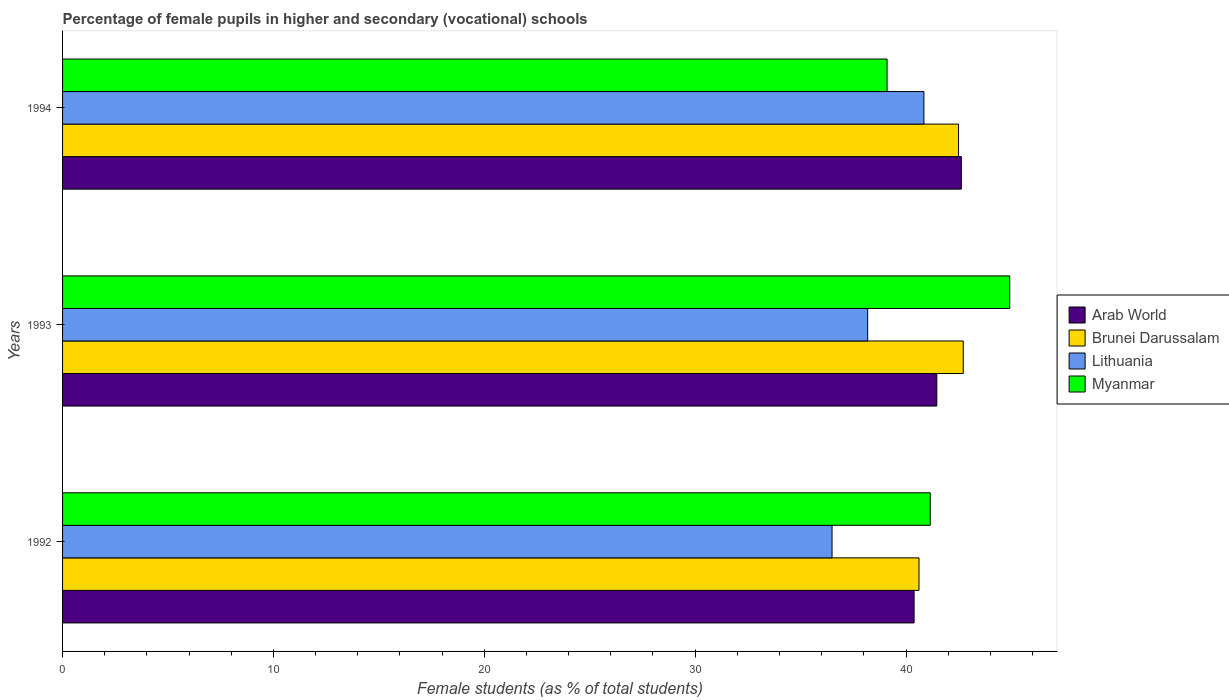How many different coloured bars are there?
Your answer should be compact. 4. How many groups of bars are there?
Provide a succinct answer. 3. How many bars are there on the 2nd tick from the top?
Your response must be concise. 4. What is the label of the 1st group of bars from the top?
Offer a very short reply. 1994. What is the percentage of female pupils in higher and secondary schools in Myanmar in 1993?
Your response must be concise. 44.92. Across all years, what is the maximum percentage of female pupils in higher and secondary schools in Myanmar?
Keep it short and to the point. 44.92. Across all years, what is the minimum percentage of female pupils in higher and secondary schools in Myanmar?
Provide a succinct answer. 39.1. In which year was the percentage of female pupils in higher and secondary schools in Lithuania minimum?
Your answer should be compact. 1992. What is the total percentage of female pupils in higher and secondary schools in Myanmar in the graph?
Your response must be concise. 125.17. What is the difference between the percentage of female pupils in higher and secondary schools in Myanmar in 1992 and that in 1994?
Give a very brief answer. 2.05. What is the difference between the percentage of female pupils in higher and secondary schools in Arab World in 1993 and the percentage of female pupils in higher and secondary schools in Brunei Darussalam in 1992?
Offer a terse response. 0.85. What is the average percentage of female pupils in higher and secondary schools in Arab World per year?
Your answer should be compact. 41.49. In the year 1992, what is the difference between the percentage of female pupils in higher and secondary schools in Lithuania and percentage of female pupils in higher and secondary schools in Arab World?
Give a very brief answer. -3.89. What is the ratio of the percentage of female pupils in higher and secondary schools in Arab World in 1992 to that in 1994?
Give a very brief answer. 0.95. Is the percentage of female pupils in higher and secondary schools in Brunei Darussalam in 1993 less than that in 1994?
Your answer should be compact. No. What is the difference between the highest and the second highest percentage of female pupils in higher and secondary schools in Arab World?
Your answer should be very brief. 1.16. What is the difference between the highest and the lowest percentage of female pupils in higher and secondary schools in Myanmar?
Your response must be concise. 5.82. Is the sum of the percentage of female pupils in higher and secondary schools in Arab World in 1993 and 1994 greater than the maximum percentage of female pupils in higher and secondary schools in Lithuania across all years?
Provide a short and direct response. Yes. Is it the case that in every year, the sum of the percentage of female pupils in higher and secondary schools in Brunei Darussalam and percentage of female pupils in higher and secondary schools in Lithuania is greater than the sum of percentage of female pupils in higher and secondary schools in Arab World and percentage of female pupils in higher and secondary schools in Myanmar?
Provide a short and direct response. No. What does the 1st bar from the top in 1992 represents?
Your response must be concise. Myanmar. What does the 2nd bar from the bottom in 1992 represents?
Offer a terse response. Brunei Darussalam. How many bars are there?
Your answer should be very brief. 12. How many years are there in the graph?
Your response must be concise. 3. What is the difference between two consecutive major ticks on the X-axis?
Provide a succinct answer. 10. Are the values on the major ticks of X-axis written in scientific E-notation?
Keep it short and to the point. No. Does the graph contain any zero values?
Give a very brief answer. No. Does the graph contain grids?
Your response must be concise. No. Where does the legend appear in the graph?
Ensure brevity in your answer.  Center right. How many legend labels are there?
Your answer should be compact. 4. How are the legend labels stacked?
Ensure brevity in your answer.  Vertical. What is the title of the graph?
Your answer should be compact. Percentage of female pupils in higher and secondary (vocational) schools. What is the label or title of the X-axis?
Provide a short and direct response. Female students (as % of total students). What is the label or title of the Y-axis?
Offer a very short reply. Years. What is the Female students (as % of total students) in Arab World in 1992?
Your response must be concise. 40.38. What is the Female students (as % of total students) of Brunei Darussalam in 1992?
Offer a very short reply. 40.62. What is the Female students (as % of total students) of Lithuania in 1992?
Provide a short and direct response. 36.49. What is the Female students (as % of total students) of Myanmar in 1992?
Offer a terse response. 41.15. What is the Female students (as % of total students) in Arab World in 1993?
Keep it short and to the point. 41.46. What is the Female students (as % of total students) of Brunei Darussalam in 1993?
Offer a terse response. 42.72. What is the Female students (as % of total students) in Lithuania in 1993?
Provide a short and direct response. 38.18. What is the Female students (as % of total students) of Myanmar in 1993?
Your answer should be compact. 44.92. What is the Female students (as % of total students) in Arab World in 1994?
Your answer should be very brief. 42.62. What is the Female students (as % of total students) of Brunei Darussalam in 1994?
Make the answer very short. 42.49. What is the Female students (as % of total students) in Lithuania in 1994?
Your answer should be compact. 40.85. What is the Female students (as % of total students) in Myanmar in 1994?
Make the answer very short. 39.1. Across all years, what is the maximum Female students (as % of total students) in Arab World?
Provide a short and direct response. 42.62. Across all years, what is the maximum Female students (as % of total students) in Brunei Darussalam?
Provide a short and direct response. 42.72. Across all years, what is the maximum Female students (as % of total students) in Lithuania?
Provide a short and direct response. 40.85. Across all years, what is the maximum Female students (as % of total students) of Myanmar?
Keep it short and to the point. 44.92. Across all years, what is the minimum Female students (as % of total students) in Arab World?
Your response must be concise. 40.38. Across all years, what is the minimum Female students (as % of total students) in Brunei Darussalam?
Ensure brevity in your answer.  40.62. Across all years, what is the minimum Female students (as % of total students) in Lithuania?
Keep it short and to the point. 36.49. Across all years, what is the minimum Female students (as % of total students) in Myanmar?
Keep it short and to the point. 39.1. What is the total Female students (as % of total students) of Arab World in the graph?
Provide a succinct answer. 124.47. What is the total Female students (as % of total students) of Brunei Darussalam in the graph?
Offer a very short reply. 125.82. What is the total Female students (as % of total students) of Lithuania in the graph?
Provide a succinct answer. 115.52. What is the total Female students (as % of total students) in Myanmar in the graph?
Your answer should be compact. 125.17. What is the difference between the Female students (as % of total students) in Arab World in 1992 and that in 1993?
Make the answer very short. -1.08. What is the difference between the Female students (as % of total students) of Brunei Darussalam in 1992 and that in 1993?
Make the answer very short. -2.1. What is the difference between the Female students (as % of total students) in Lithuania in 1992 and that in 1993?
Offer a very short reply. -1.69. What is the difference between the Female students (as % of total students) of Myanmar in 1992 and that in 1993?
Offer a terse response. -3.77. What is the difference between the Female students (as % of total students) in Arab World in 1992 and that in 1994?
Keep it short and to the point. -2.24. What is the difference between the Female students (as % of total students) of Brunei Darussalam in 1992 and that in 1994?
Offer a very short reply. -1.88. What is the difference between the Female students (as % of total students) of Lithuania in 1992 and that in 1994?
Your response must be concise. -4.36. What is the difference between the Female students (as % of total students) of Myanmar in 1992 and that in 1994?
Provide a succinct answer. 2.05. What is the difference between the Female students (as % of total students) of Arab World in 1993 and that in 1994?
Offer a very short reply. -1.16. What is the difference between the Female students (as % of total students) of Brunei Darussalam in 1993 and that in 1994?
Your answer should be compact. 0.22. What is the difference between the Female students (as % of total students) in Lithuania in 1993 and that in 1994?
Keep it short and to the point. -2.67. What is the difference between the Female students (as % of total students) of Myanmar in 1993 and that in 1994?
Your response must be concise. 5.82. What is the difference between the Female students (as % of total students) of Arab World in 1992 and the Female students (as % of total students) of Brunei Darussalam in 1993?
Your answer should be very brief. -2.33. What is the difference between the Female students (as % of total students) of Arab World in 1992 and the Female students (as % of total students) of Lithuania in 1993?
Make the answer very short. 2.2. What is the difference between the Female students (as % of total students) of Arab World in 1992 and the Female students (as % of total students) of Myanmar in 1993?
Offer a very short reply. -4.54. What is the difference between the Female students (as % of total students) in Brunei Darussalam in 1992 and the Female students (as % of total students) in Lithuania in 1993?
Give a very brief answer. 2.43. What is the difference between the Female students (as % of total students) of Brunei Darussalam in 1992 and the Female students (as % of total students) of Myanmar in 1993?
Offer a terse response. -4.3. What is the difference between the Female students (as % of total students) in Lithuania in 1992 and the Female students (as % of total students) in Myanmar in 1993?
Provide a succinct answer. -8.43. What is the difference between the Female students (as % of total students) of Arab World in 1992 and the Female students (as % of total students) of Brunei Darussalam in 1994?
Offer a terse response. -2.11. What is the difference between the Female students (as % of total students) of Arab World in 1992 and the Female students (as % of total students) of Lithuania in 1994?
Ensure brevity in your answer.  -0.47. What is the difference between the Female students (as % of total students) of Arab World in 1992 and the Female students (as % of total students) of Myanmar in 1994?
Your response must be concise. 1.28. What is the difference between the Female students (as % of total students) in Brunei Darussalam in 1992 and the Female students (as % of total students) in Lithuania in 1994?
Your answer should be very brief. -0.23. What is the difference between the Female students (as % of total students) of Brunei Darussalam in 1992 and the Female students (as % of total students) of Myanmar in 1994?
Offer a terse response. 1.51. What is the difference between the Female students (as % of total students) of Lithuania in 1992 and the Female students (as % of total students) of Myanmar in 1994?
Ensure brevity in your answer.  -2.61. What is the difference between the Female students (as % of total students) in Arab World in 1993 and the Female students (as % of total students) in Brunei Darussalam in 1994?
Give a very brief answer. -1.03. What is the difference between the Female students (as % of total students) in Arab World in 1993 and the Female students (as % of total students) in Lithuania in 1994?
Make the answer very short. 0.61. What is the difference between the Female students (as % of total students) in Arab World in 1993 and the Female students (as % of total students) in Myanmar in 1994?
Offer a very short reply. 2.36. What is the difference between the Female students (as % of total students) in Brunei Darussalam in 1993 and the Female students (as % of total students) in Lithuania in 1994?
Keep it short and to the point. 1.87. What is the difference between the Female students (as % of total students) in Brunei Darussalam in 1993 and the Female students (as % of total students) in Myanmar in 1994?
Your response must be concise. 3.61. What is the difference between the Female students (as % of total students) in Lithuania in 1993 and the Female students (as % of total students) in Myanmar in 1994?
Ensure brevity in your answer.  -0.92. What is the average Female students (as % of total students) in Arab World per year?
Make the answer very short. 41.49. What is the average Female students (as % of total students) in Brunei Darussalam per year?
Your response must be concise. 41.94. What is the average Female students (as % of total students) of Lithuania per year?
Provide a short and direct response. 38.51. What is the average Female students (as % of total students) of Myanmar per year?
Offer a very short reply. 41.72. In the year 1992, what is the difference between the Female students (as % of total students) in Arab World and Female students (as % of total students) in Brunei Darussalam?
Keep it short and to the point. -0.23. In the year 1992, what is the difference between the Female students (as % of total students) in Arab World and Female students (as % of total students) in Lithuania?
Offer a terse response. 3.89. In the year 1992, what is the difference between the Female students (as % of total students) of Arab World and Female students (as % of total students) of Myanmar?
Your answer should be very brief. -0.77. In the year 1992, what is the difference between the Female students (as % of total students) of Brunei Darussalam and Female students (as % of total students) of Lithuania?
Your answer should be very brief. 4.12. In the year 1992, what is the difference between the Female students (as % of total students) of Brunei Darussalam and Female students (as % of total students) of Myanmar?
Keep it short and to the point. -0.53. In the year 1992, what is the difference between the Female students (as % of total students) in Lithuania and Female students (as % of total students) in Myanmar?
Give a very brief answer. -4.66. In the year 1993, what is the difference between the Female students (as % of total students) of Arab World and Female students (as % of total students) of Brunei Darussalam?
Make the answer very short. -1.25. In the year 1993, what is the difference between the Female students (as % of total students) of Arab World and Female students (as % of total students) of Lithuania?
Make the answer very short. 3.28. In the year 1993, what is the difference between the Female students (as % of total students) in Arab World and Female students (as % of total students) in Myanmar?
Your answer should be compact. -3.46. In the year 1993, what is the difference between the Female students (as % of total students) of Brunei Darussalam and Female students (as % of total students) of Lithuania?
Give a very brief answer. 4.53. In the year 1993, what is the difference between the Female students (as % of total students) of Brunei Darussalam and Female students (as % of total students) of Myanmar?
Your answer should be compact. -2.2. In the year 1993, what is the difference between the Female students (as % of total students) in Lithuania and Female students (as % of total students) in Myanmar?
Keep it short and to the point. -6.74. In the year 1994, what is the difference between the Female students (as % of total students) in Arab World and Female students (as % of total students) in Brunei Darussalam?
Offer a very short reply. 0.13. In the year 1994, what is the difference between the Female students (as % of total students) in Arab World and Female students (as % of total students) in Lithuania?
Keep it short and to the point. 1.77. In the year 1994, what is the difference between the Female students (as % of total students) in Arab World and Female students (as % of total students) in Myanmar?
Keep it short and to the point. 3.52. In the year 1994, what is the difference between the Female students (as % of total students) of Brunei Darussalam and Female students (as % of total students) of Lithuania?
Give a very brief answer. 1.64. In the year 1994, what is the difference between the Female students (as % of total students) of Brunei Darussalam and Female students (as % of total students) of Myanmar?
Keep it short and to the point. 3.39. In the year 1994, what is the difference between the Female students (as % of total students) in Lithuania and Female students (as % of total students) in Myanmar?
Your answer should be very brief. 1.75. What is the ratio of the Female students (as % of total students) of Arab World in 1992 to that in 1993?
Your answer should be compact. 0.97. What is the ratio of the Female students (as % of total students) in Brunei Darussalam in 1992 to that in 1993?
Keep it short and to the point. 0.95. What is the ratio of the Female students (as % of total students) in Lithuania in 1992 to that in 1993?
Your answer should be very brief. 0.96. What is the ratio of the Female students (as % of total students) in Myanmar in 1992 to that in 1993?
Your answer should be compact. 0.92. What is the ratio of the Female students (as % of total students) of Arab World in 1992 to that in 1994?
Your answer should be very brief. 0.95. What is the ratio of the Female students (as % of total students) in Brunei Darussalam in 1992 to that in 1994?
Ensure brevity in your answer.  0.96. What is the ratio of the Female students (as % of total students) in Lithuania in 1992 to that in 1994?
Offer a terse response. 0.89. What is the ratio of the Female students (as % of total students) of Myanmar in 1992 to that in 1994?
Your response must be concise. 1.05. What is the ratio of the Female students (as % of total students) of Arab World in 1993 to that in 1994?
Your answer should be very brief. 0.97. What is the ratio of the Female students (as % of total students) of Brunei Darussalam in 1993 to that in 1994?
Your answer should be compact. 1.01. What is the ratio of the Female students (as % of total students) of Lithuania in 1993 to that in 1994?
Make the answer very short. 0.93. What is the ratio of the Female students (as % of total students) in Myanmar in 1993 to that in 1994?
Offer a terse response. 1.15. What is the difference between the highest and the second highest Female students (as % of total students) in Arab World?
Your answer should be very brief. 1.16. What is the difference between the highest and the second highest Female students (as % of total students) in Brunei Darussalam?
Make the answer very short. 0.22. What is the difference between the highest and the second highest Female students (as % of total students) of Lithuania?
Your answer should be very brief. 2.67. What is the difference between the highest and the second highest Female students (as % of total students) in Myanmar?
Offer a terse response. 3.77. What is the difference between the highest and the lowest Female students (as % of total students) of Arab World?
Keep it short and to the point. 2.24. What is the difference between the highest and the lowest Female students (as % of total students) in Brunei Darussalam?
Provide a succinct answer. 2.1. What is the difference between the highest and the lowest Female students (as % of total students) of Lithuania?
Provide a short and direct response. 4.36. What is the difference between the highest and the lowest Female students (as % of total students) in Myanmar?
Your answer should be very brief. 5.82. 